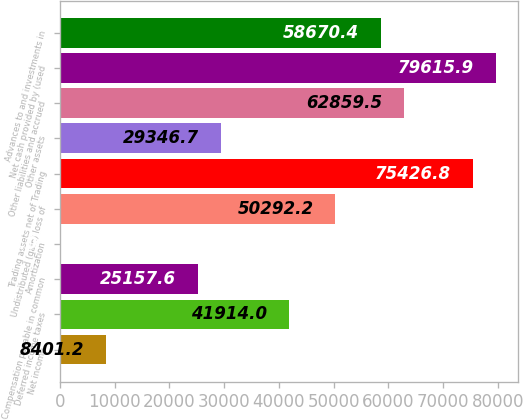Convert chart. <chart><loc_0><loc_0><loc_500><loc_500><bar_chart><fcel>Net income<fcel>Deferred income taxes<fcel>Compensation payable in common<fcel>Amortization<fcel>Undistributed (gain) loss of<fcel>Trading assets net of Trading<fcel>Other assets<fcel>Other liabilities and accrued<fcel>Net cash provided by (used<fcel>Advances to and investments in<nl><fcel>8401.2<fcel>41914<fcel>25157.6<fcel>23<fcel>50292.2<fcel>75426.8<fcel>29346.7<fcel>62859.5<fcel>79615.9<fcel>58670.4<nl></chart> 